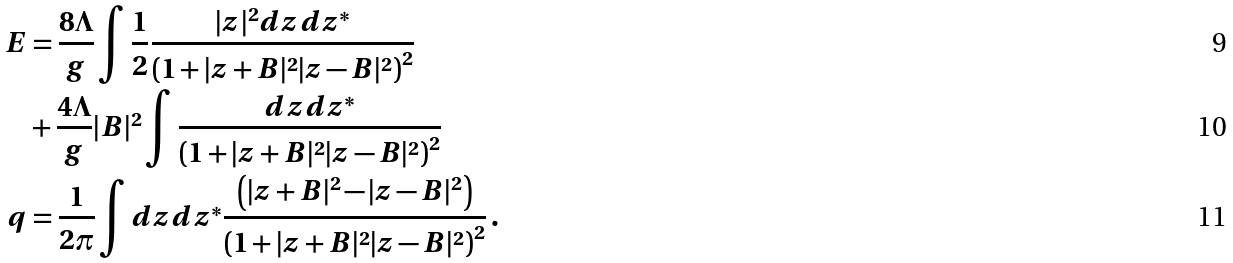<formula> <loc_0><loc_0><loc_500><loc_500>E & = \frac { 8 \Lambda } { g } \int \frac { 1 } { 2 } \frac { | z | ^ { 2 } d z d z ^ { * } } { \left ( 1 + | z + B | ^ { 2 } | z - B | ^ { 2 } \right ) ^ { 2 } } \\ & + \frac { 4 \Lambda } { g } | B | ^ { 2 } \int \frac { d z d z ^ { * } } { \left ( 1 + | z + B | ^ { 2 } | z - B | ^ { 2 } \right ) ^ { 2 } } \\ q & = \frac { 1 } { 2 \pi } \int d z d z ^ { * } \frac { \left ( | z + B | ^ { 2 } - | z - B | ^ { 2 } \right ) } { \left ( 1 + | z + B | ^ { 2 } | z - B | ^ { 2 } \right ) ^ { 2 } } \, .</formula> 